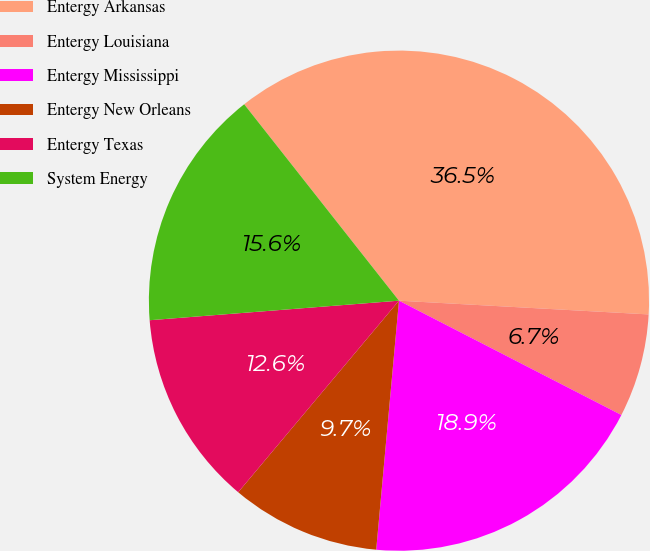Convert chart. <chart><loc_0><loc_0><loc_500><loc_500><pie_chart><fcel>Entergy Arkansas<fcel>Entergy Louisiana<fcel>Entergy Mississippi<fcel>Entergy New Orleans<fcel>Entergy Texas<fcel>System Energy<nl><fcel>36.49%<fcel>6.68%<fcel>18.89%<fcel>9.66%<fcel>12.64%<fcel>15.62%<nl></chart> 